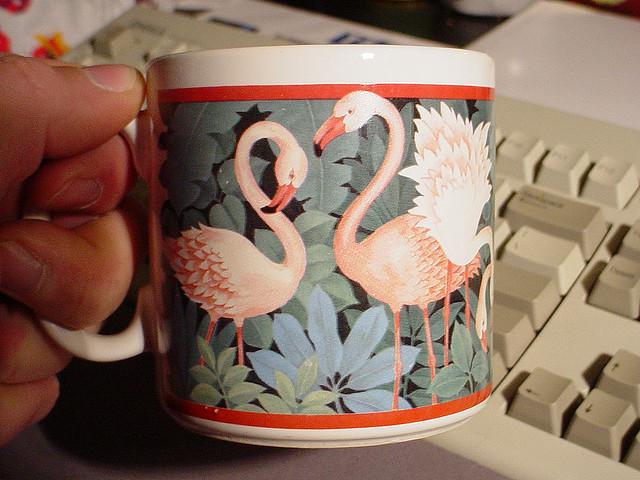What color is the bottom of the cup?
Keep it brief. White. What object is in the background of this picture?
Answer briefly. Keyboard. In which hand is someone holding the mug?
Be succinct. Left. What animals are on the mug?
Quick response, please. Flamingos. What flowers are written on the side of the cup?
Quick response, please. None. 